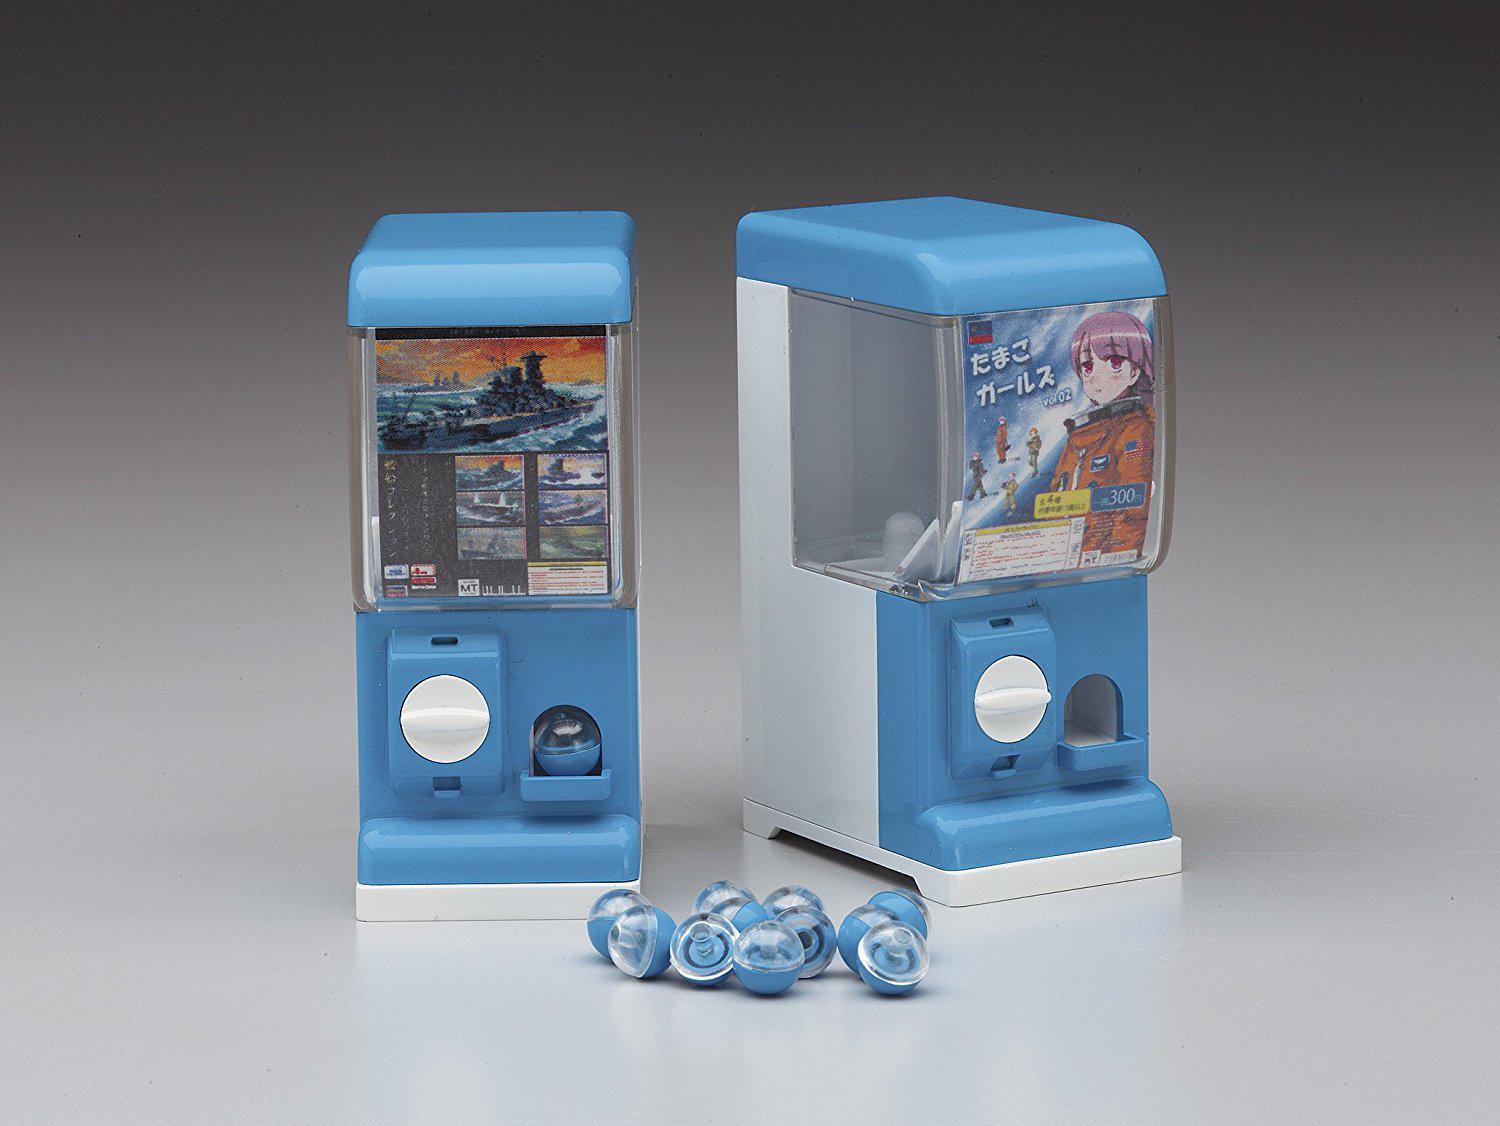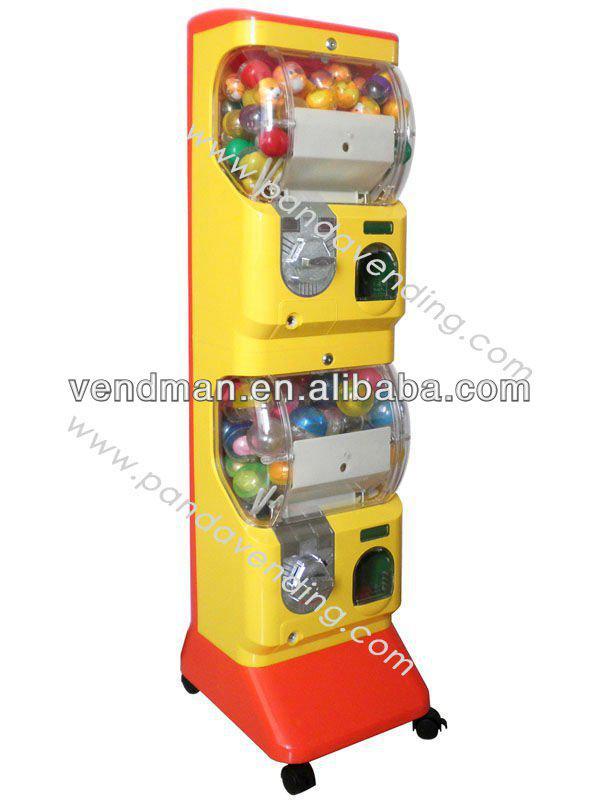The first image is the image on the left, the second image is the image on the right. For the images displayed, is the sentence "There are exactly 3 toy vending machines." factually correct? Answer yes or no. Yes. 